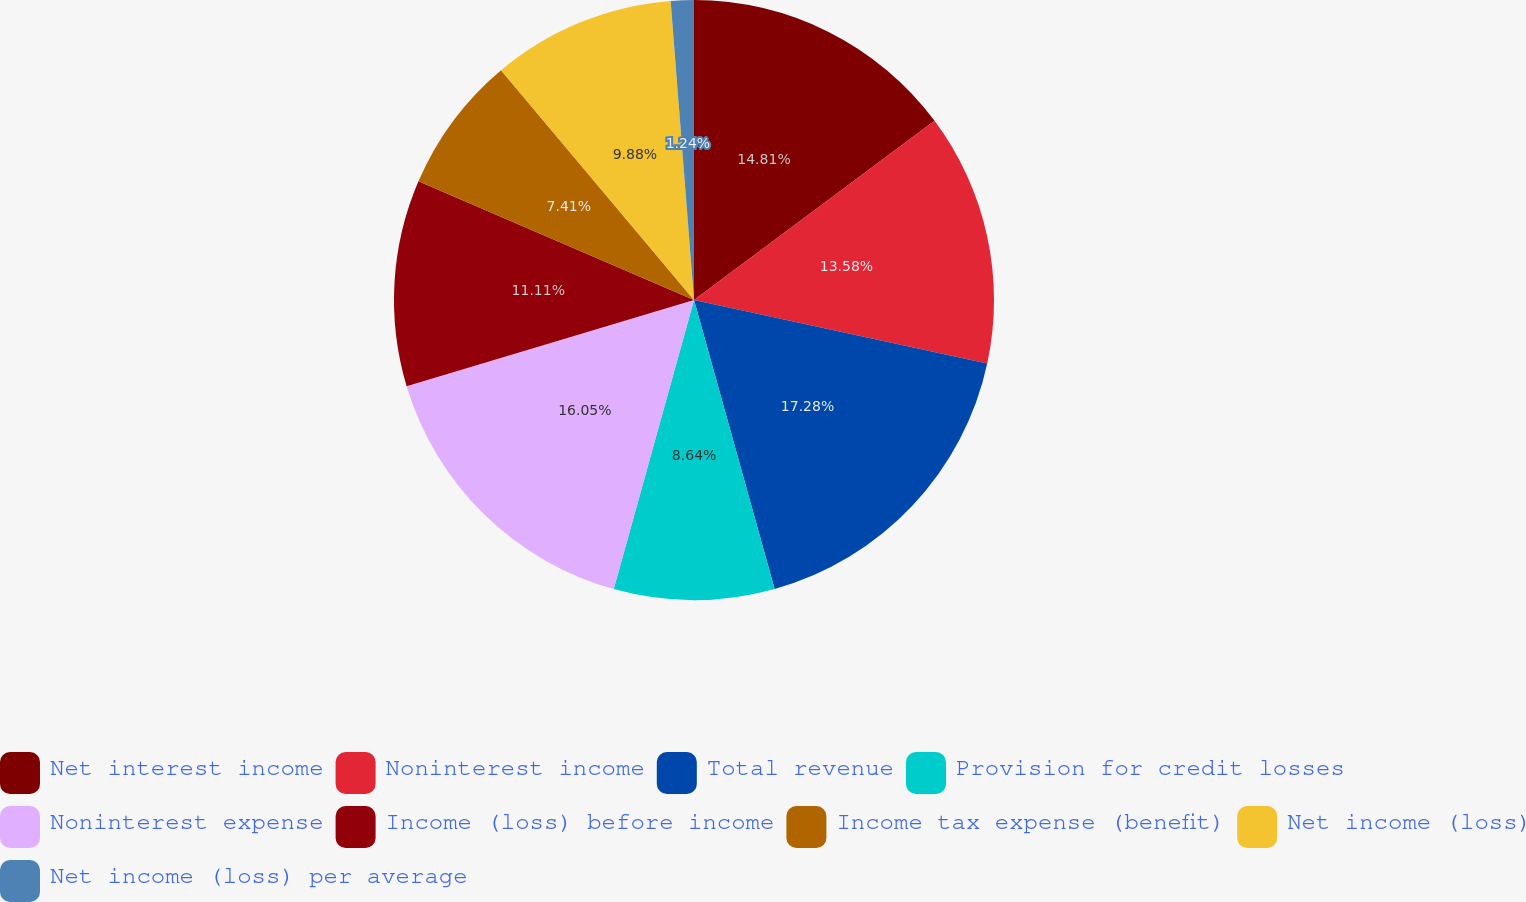<chart> <loc_0><loc_0><loc_500><loc_500><pie_chart><fcel>Net interest income<fcel>Noninterest income<fcel>Total revenue<fcel>Provision for credit losses<fcel>Noninterest expense<fcel>Income (loss) before income<fcel>Income tax expense (benefit)<fcel>Net income (loss)<fcel>Net income (loss) per average<nl><fcel>14.81%<fcel>13.58%<fcel>17.28%<fcel>8.64%<fcel>16.05%<fcel>11.11%<fcel>7.41%<fcel>9.88%<fcel>1.24%<nl></chart> 